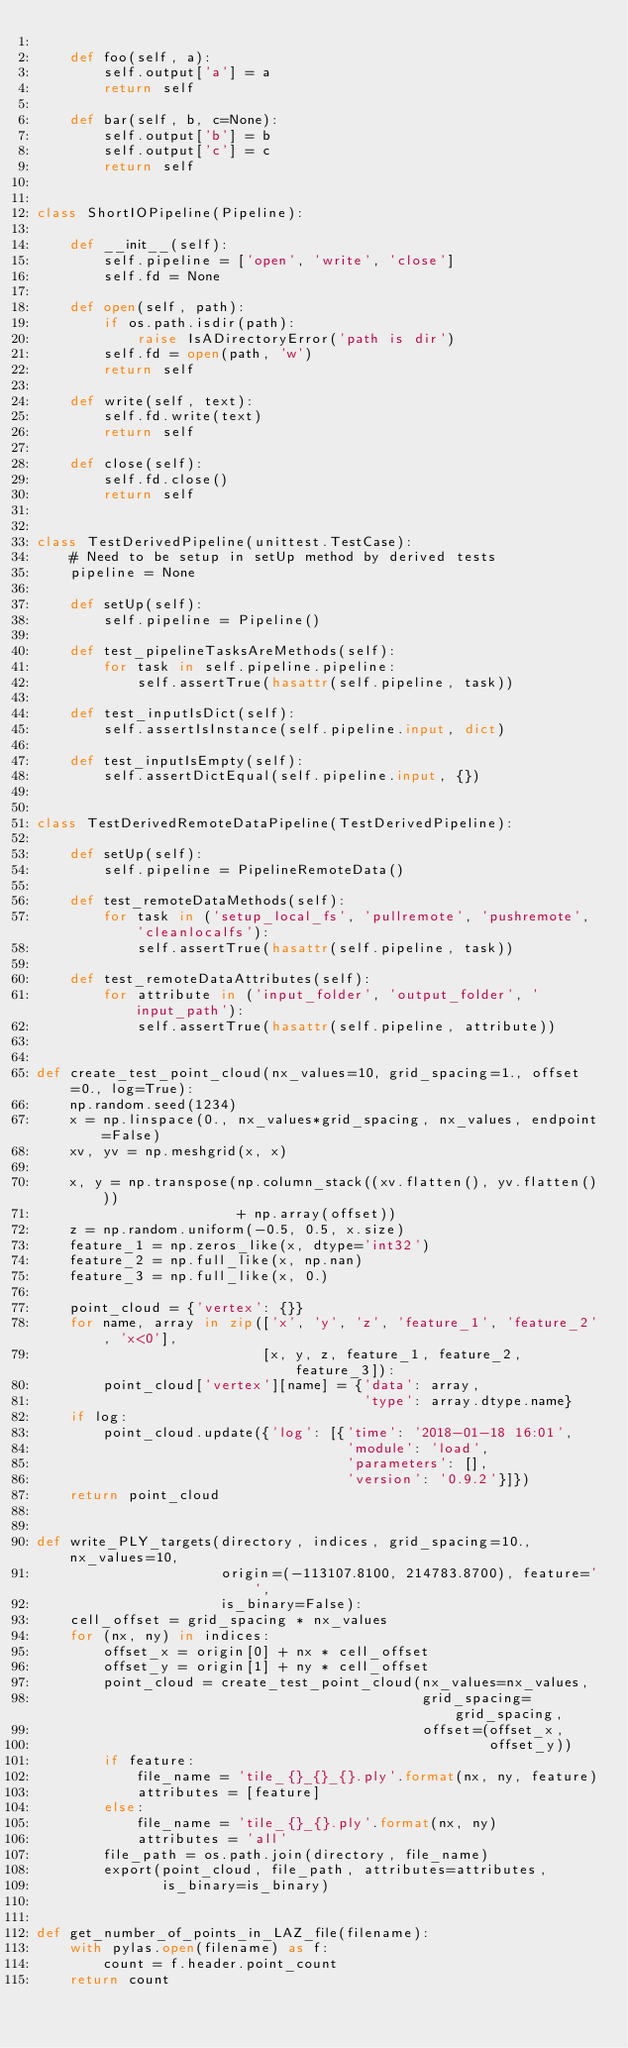Convert code to text. <code><loc_0><loc_0><loc_500><loc_500><_Python_>
    def foo(self, a):
        self.output['a'] = a
        return self

    def bar(self, b, c=None):
        self.output['b'] = b
        self.output['c'] = c
        return self


class ShortIOPipeline(Pipeline):

    def __init__(self):
        self.pipeline = ['open', 'write', 'close']
        self.fd = None

    def open(self, path):
        if os.path.isdir(path):
            raise IsADirectoryError('path is dir')
        self.fd = open(path, 'w')
        return self

    def write(self, text):
        self.fd.write(text)
        return self

    def close(self):
        self.fd.close()
        return self


class TestDerivedPipeline(unittest.TestCase):
    # Need to be setup in setUp method by derived tests
    pipeline = None

    def setUp(self):
        self.pipeline = Pipeline()

    def test_pipelineTasksAreMethods(self):
        for task in self.pipeline.pipeline:
            self.assertTrue(hasattr(self.pipeline, task))

    def test_inputIsDict(self):
        self.assertIsInstance(self.pipeline.input, dict)

    def test_inputIsEmpty(self):
        self.assertDictEqual(self.pipeline.input, {})


class TestDerivedRemoteDataPipeline(TestDerivedPipeline):

    def setUp(self):
        self.pipeline = PipelineRemoteData()

    def test_remoteDataMethods(self):
        for task in ('setup_local_fs', 'pullremote', 'pushremote', 'cleanlocalfs'):
            self.assertTrue(hasattr(self.pipeline, task))

    def test_remoteDataAttributes(self):
        for attribute in ('input_folder', 'output_folder', 'input_path'):
            self.assertTrue(hasattr(self.pipeline, attribute))


def create_test_point_cloud(nx_values=10, grid_spacing=1., offset=0., log=True):
    np.random.seed(1234)
    x = np.linspace(0., nx_values*grid_spacing, nx_values, endpoint=False)
    xv, yv = np.meshgrid(x, x)

    x, y = np.transpose(np.column_stack((xv.flatten(), yv.flatten()))
                        + np.array(offset))
    z = np.random.uniform(-0.5, 0.5, x.size)
    feature_1 = np.zeros_like(x, dtype='int32')
    feature_2 = np.full_like(x, np.nan)
    feature_3 = np.full_like(x, 0.)

    point_cloud = {'vertex': {}}
    for name, array in zip(['x', 'y', 'z', 'feature_1', 'feature_2', 'x<0'],
                           [x, y, z, feature_1, feature_2, feature_3]):
        point_cloud['vertex'][name] = {'data': array,
                                       'type': array.dtype.name}
    if log:
        point_cloud.update({'log': [{'time': '2018-01-18 16:01',
                                     'module': 'load',
                                     'parameters': [],
                                     'version': '0.9.2'}]})
    return point_cloud


def write_PLY_targets(directory, indices, grid_spacing=10., nx_values=10,
                      origin=(-113107.8100, 214783.8700), feature='',
                      is_binary=False):
    cell_offset = grid_spacing * nx_values
    for (nx, ny) in indices:
        offset_x = origin[0] + nx * cell_offset
        offset_y = origin[1] + ny * cell_offset
        point_cloud = create_test_point_cloud(nx_values=nx_values,
                                              grid_spacing=grid_spacing,
                                              offset=(offset_x,
                                                      offset_y))
        if feature:
            file_name = 'tile_{}_{}_{}.ply'.format(nx, ny, feature)
            attributes = [feature]
        else:
            file_name = 'tile_{}_{}.ply'.format(nx, ny)
            attributes = 'all'
        file_path = os.path.join(directory, file_name)
        export(point_cloud, file_path, attributes=attributes,
               is_binary=is_binary)


def get_number_of_points_in_LAZ_file(filename):
    with pylas.open(filename) as f:
        count = f.header.point_count
    return count
</code> 